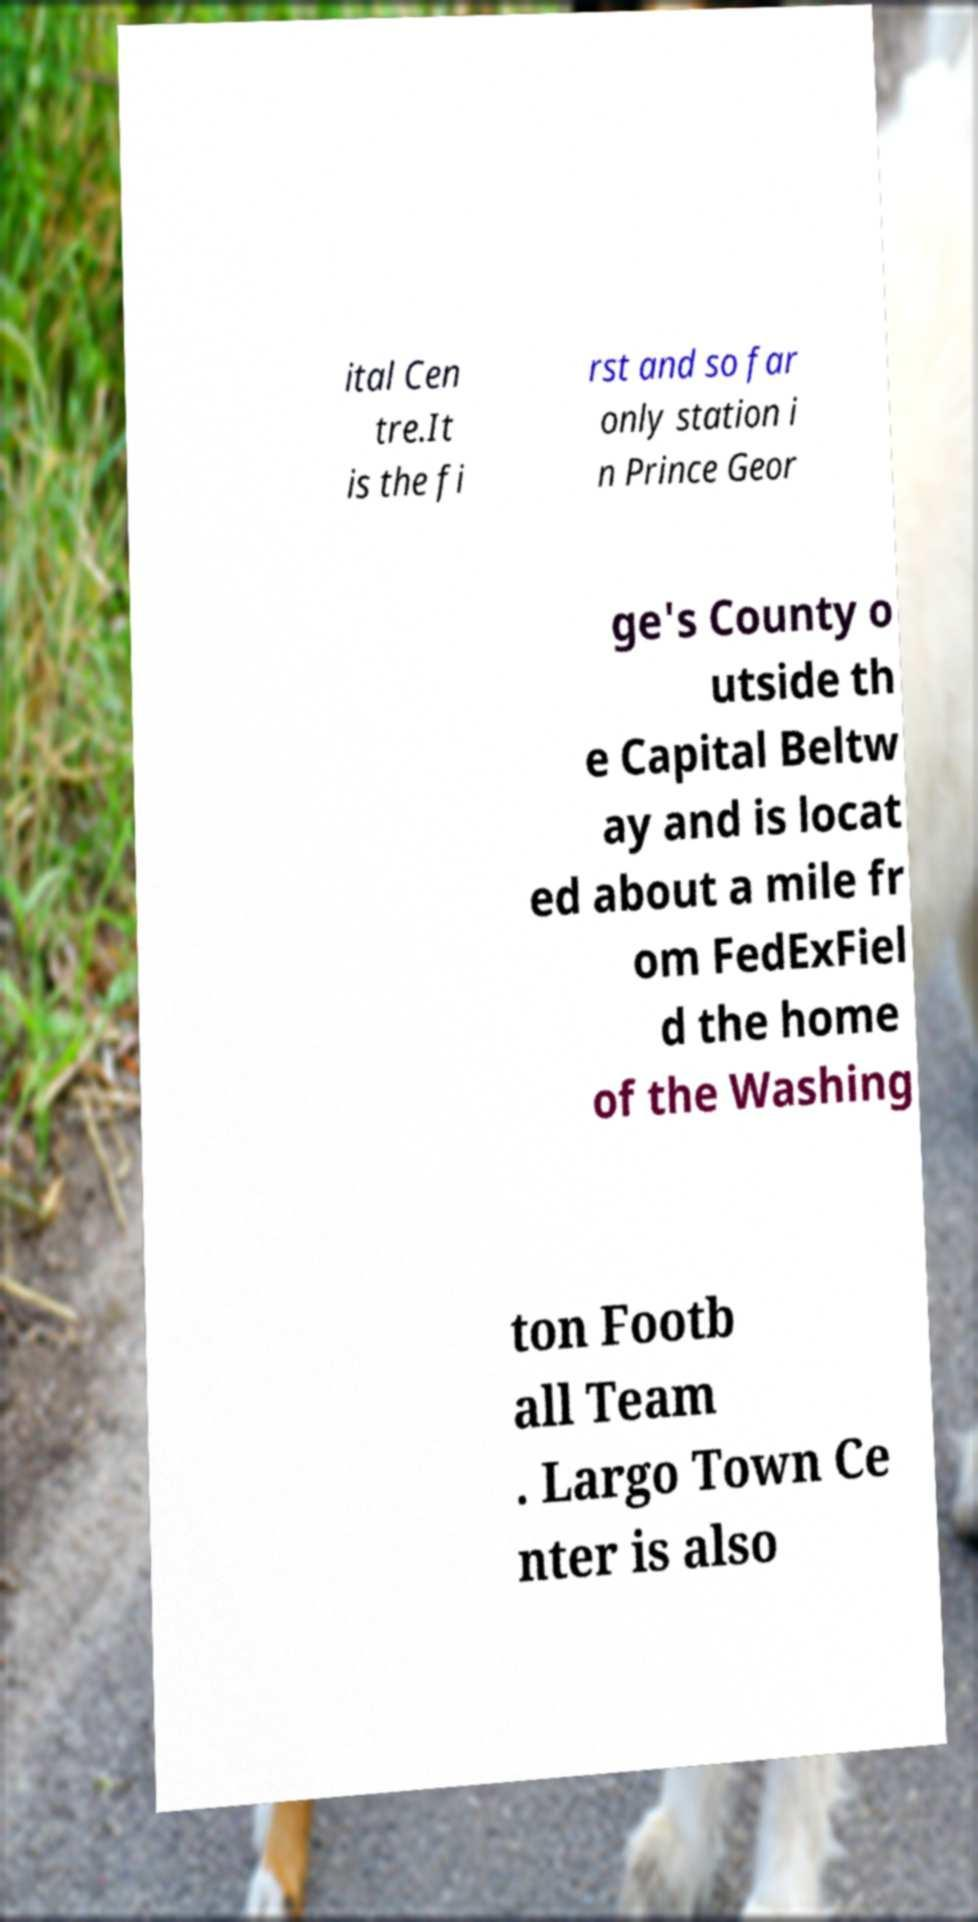There's text embedded in this image that I need extracted. Can you transcribe it verbatim? ital Cen tre.It is the fi rst and so far only station i n Prince Geor ge's County o utside th e Capital Beltw ay and is locat ed about a mile fr om FedExFiel d the home of the Washing ton Footb all Team . Largo Town Ce nter is also 